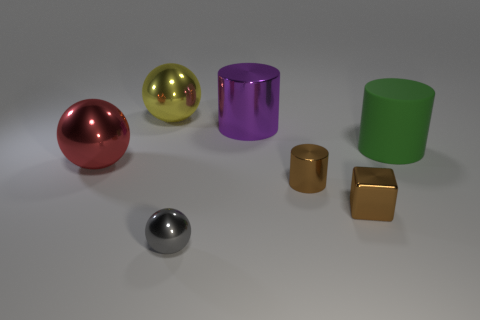Add 2 purple matte cylinders. How many objects exist? 9 Subtract all cubes. How many objects are left? 6 Add 3 purple cylinders. How many purple cylinders are left? 4 Add 2 yellow objects. How many yellow objects exist? 3 Subtract 0 cyan cubes. How many objects are left? 7 Subtract all big green cylinders. Subtract all large brown matte cylinders. How many objects are left? 6 